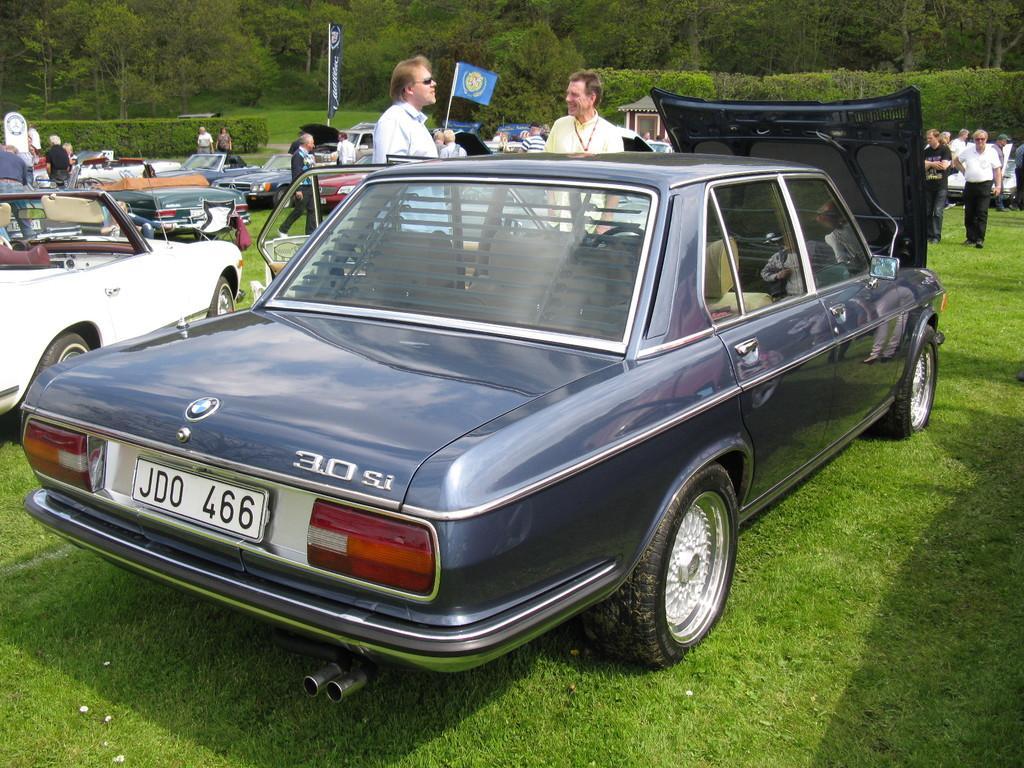Could you give a brief overview of what you see in this image? In this image I can see many vehicles on the ground. To the side of these vehicles I can see the group of people with different color dresses. In the background I can see the banner, flag, a small hut and many trees. 